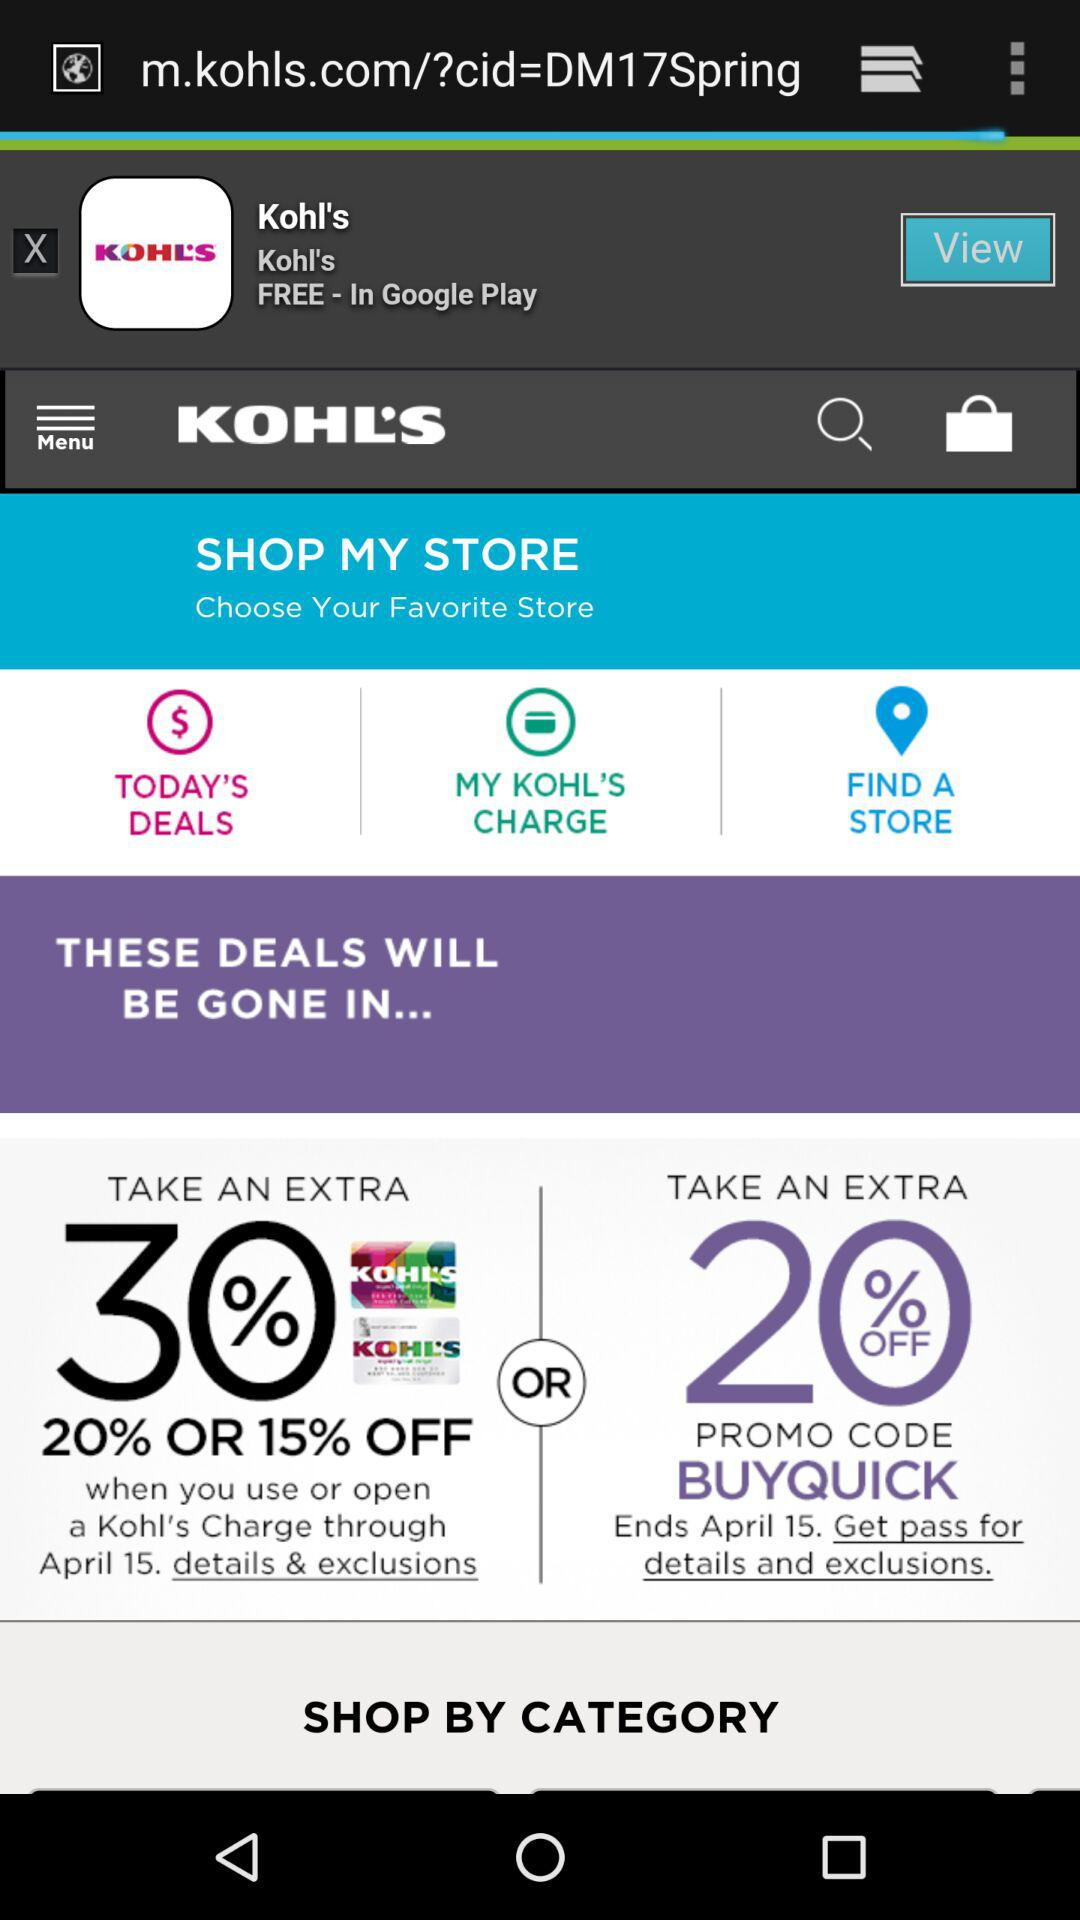When will the deal expire? The deal will expire on April 15. 